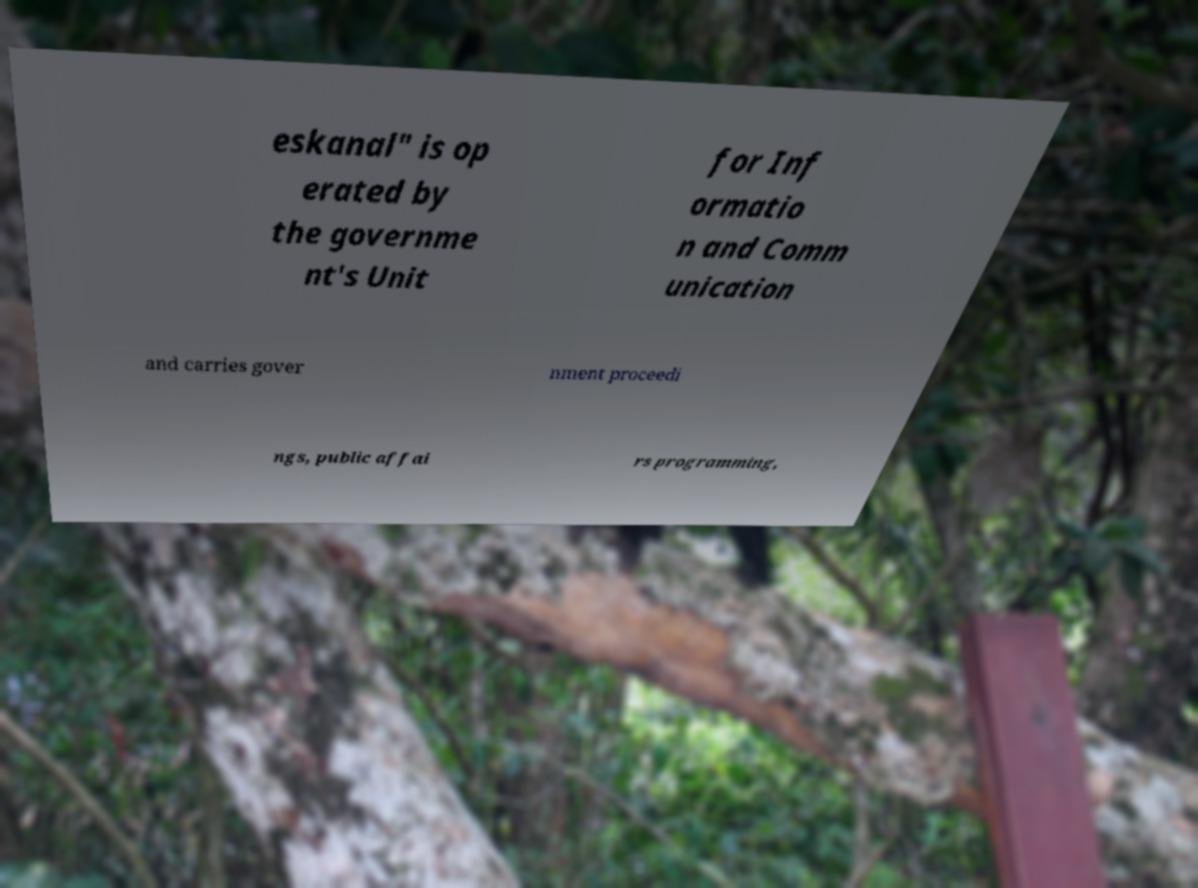Could you assist in decoding the text presented in this image and type it out clearly? eskanal" is op erated by the governme nt's Unit for Inf ormatio n and Comm unication and carries gover nment proceedi ngs, public affai rs programming, 